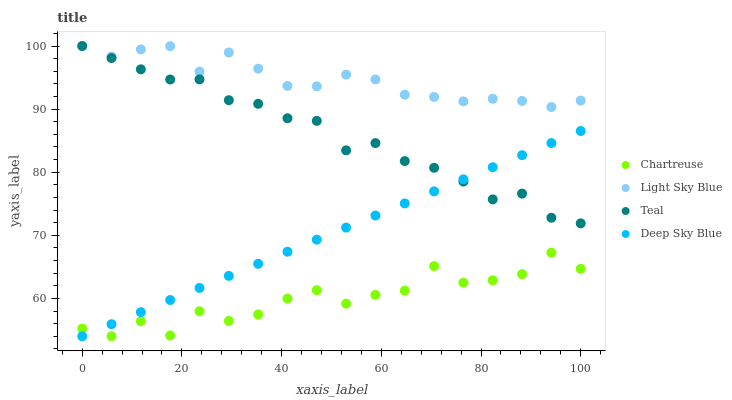Does Chartreuse have the minimum area under the curve?
Answer yes or no. Yes. Does Light Sky Blue have the maximum area under the curve?
Answer yes or no. Yes. Does Deep Sky Blue have the minimum area under the curve?
Answer yes or no. No. Does Deep Sky Blue have the maximum area under the curve?
Answer yes or no. No. Is Deep Sky Blue the smoothest?
Answer yes or no. Yes. Is Chartreuse the roughest?
Answer yes or no. Yes. Is Light Sky Blue the smoothest?
Answer yes or no. No. Is Light Sky Blue the roughest?
Answer yes or no. No. Does Chartreuse have the lowest value?
Answer yes or no. Yes. Does Light Sky Blue have the lowest value?
Answer yes or no. No. Does Teal have the highest value?
Answer yes or no. Yes. Does Deep Sky Blue have the highest value?
Answer yes or no. No. Is Chartreuse less than Teal?
Answer yes or no. Yes. Is Light Sky Blue greater than Chartreuse?
Answer yes or no. Yes. Does Deep Sky Blue intersect Teal?
Answer yes or no. Yes. Is Deep Sky Blue less than Teal?
Answer yes or no. No. Is Deep Sky Blue greater than Teal?
Answer yes or no. No. Does Chartreuse intersect Teal?
Answer yes or no. No. 